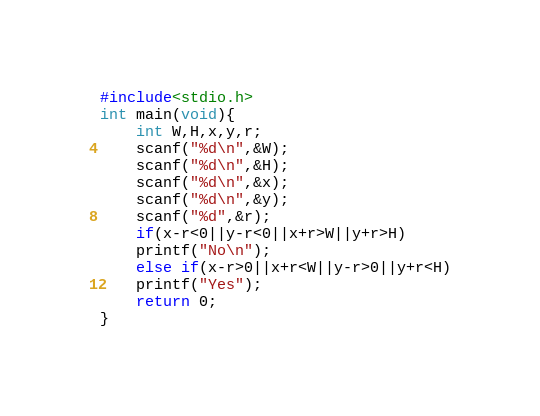<code> <loc_0><loc_0><loc_500><loc_500><_C_>#include<stdio.h>
int main(void){
	int W,H,x,y,r;
	scanf("%d\n",&W);
	scanf("%d\n",&H);
	scanf("%d\n",&x);
	scanf("%d\n",&y);
	scanf("%d",&r);
	if(x-r<0||y-r<0||x+r>W||y+r>H)
	printf("No\n");
	else if(x-r>0||x+r<W||y-r>0||y+r<H)
	printf("Yes");
	return 0;
}</code> 